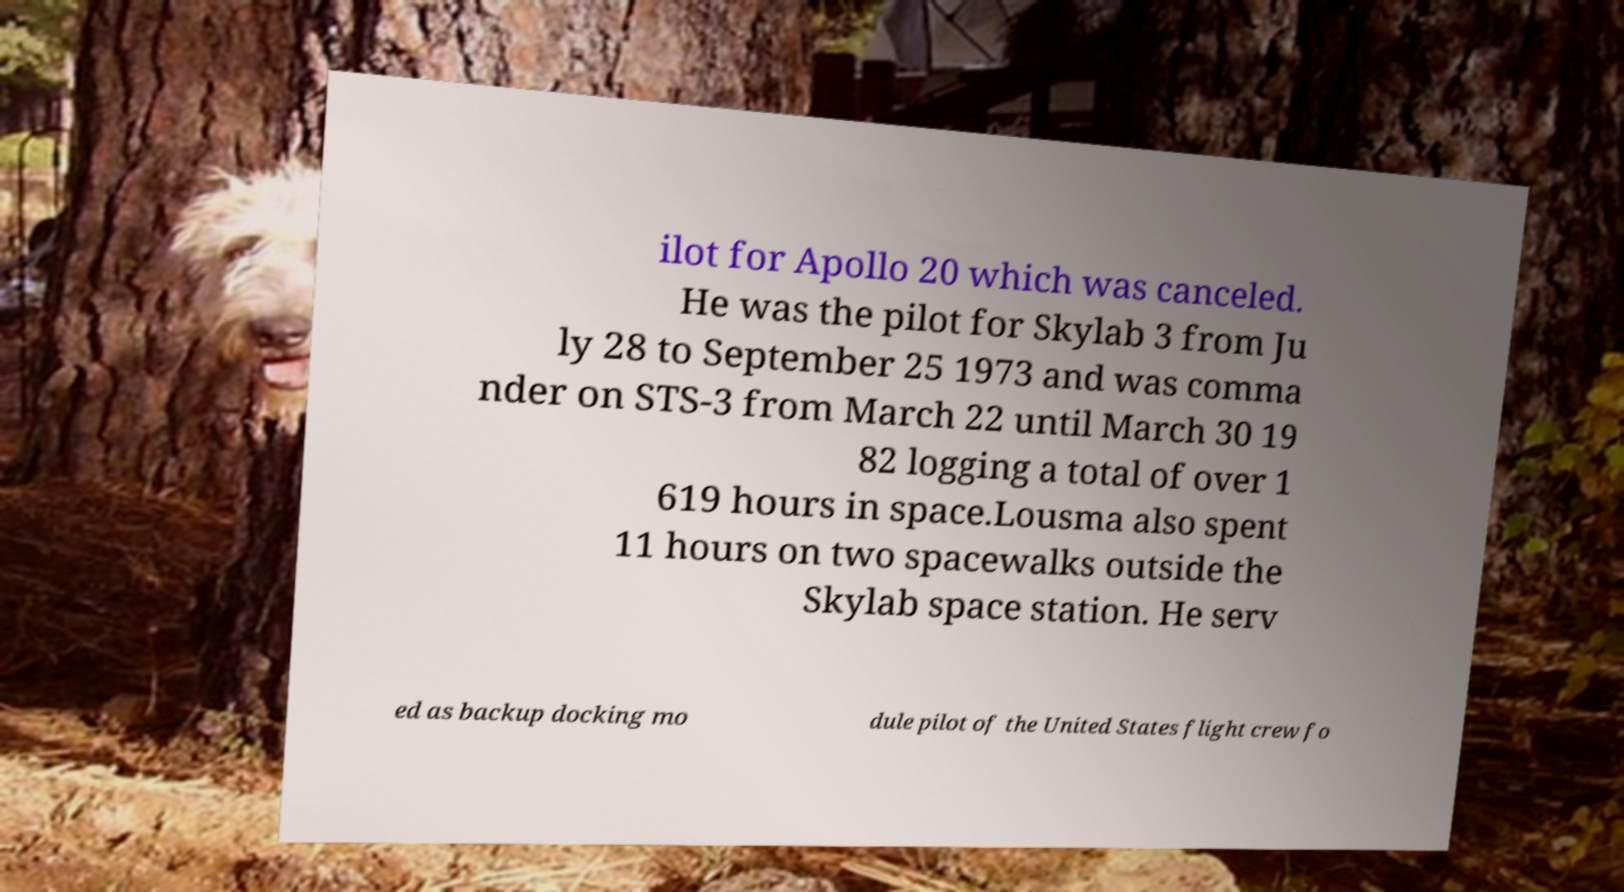Could you assist in decoding the text presented in this image and type it out clearly? ilot for Apollo 20 which was canceled. He was the pilot for Skylab 3 from Ju ly 28 to September 25 1973 and was comma nder on STS-3 from March 22 until March 30 19 82 logging a total of over 1 619 hours in space.Lousma also spent 11 hours on two spacewalks outside the Skylab space station. He serv ed as backup docking mo dule pilot of the United States flight crew fo 